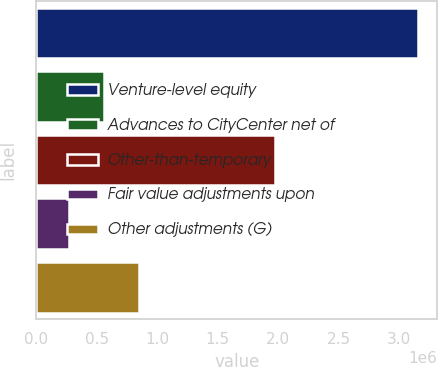<chart> <loc_0><loc_0><loc_500><loc_500><bar_chart><fcel>Venture-level equity<fcel>Advances to CityCenter net of<fcel>Other-than-temporary<fcel>Fair value adjustments upon<fcel>Other adjustments (G)<nl><fcel>3.15663e+06<fcel>556134<fcel>1.97263e+06<fcel>267190<fcel>845078<nl></chart> 